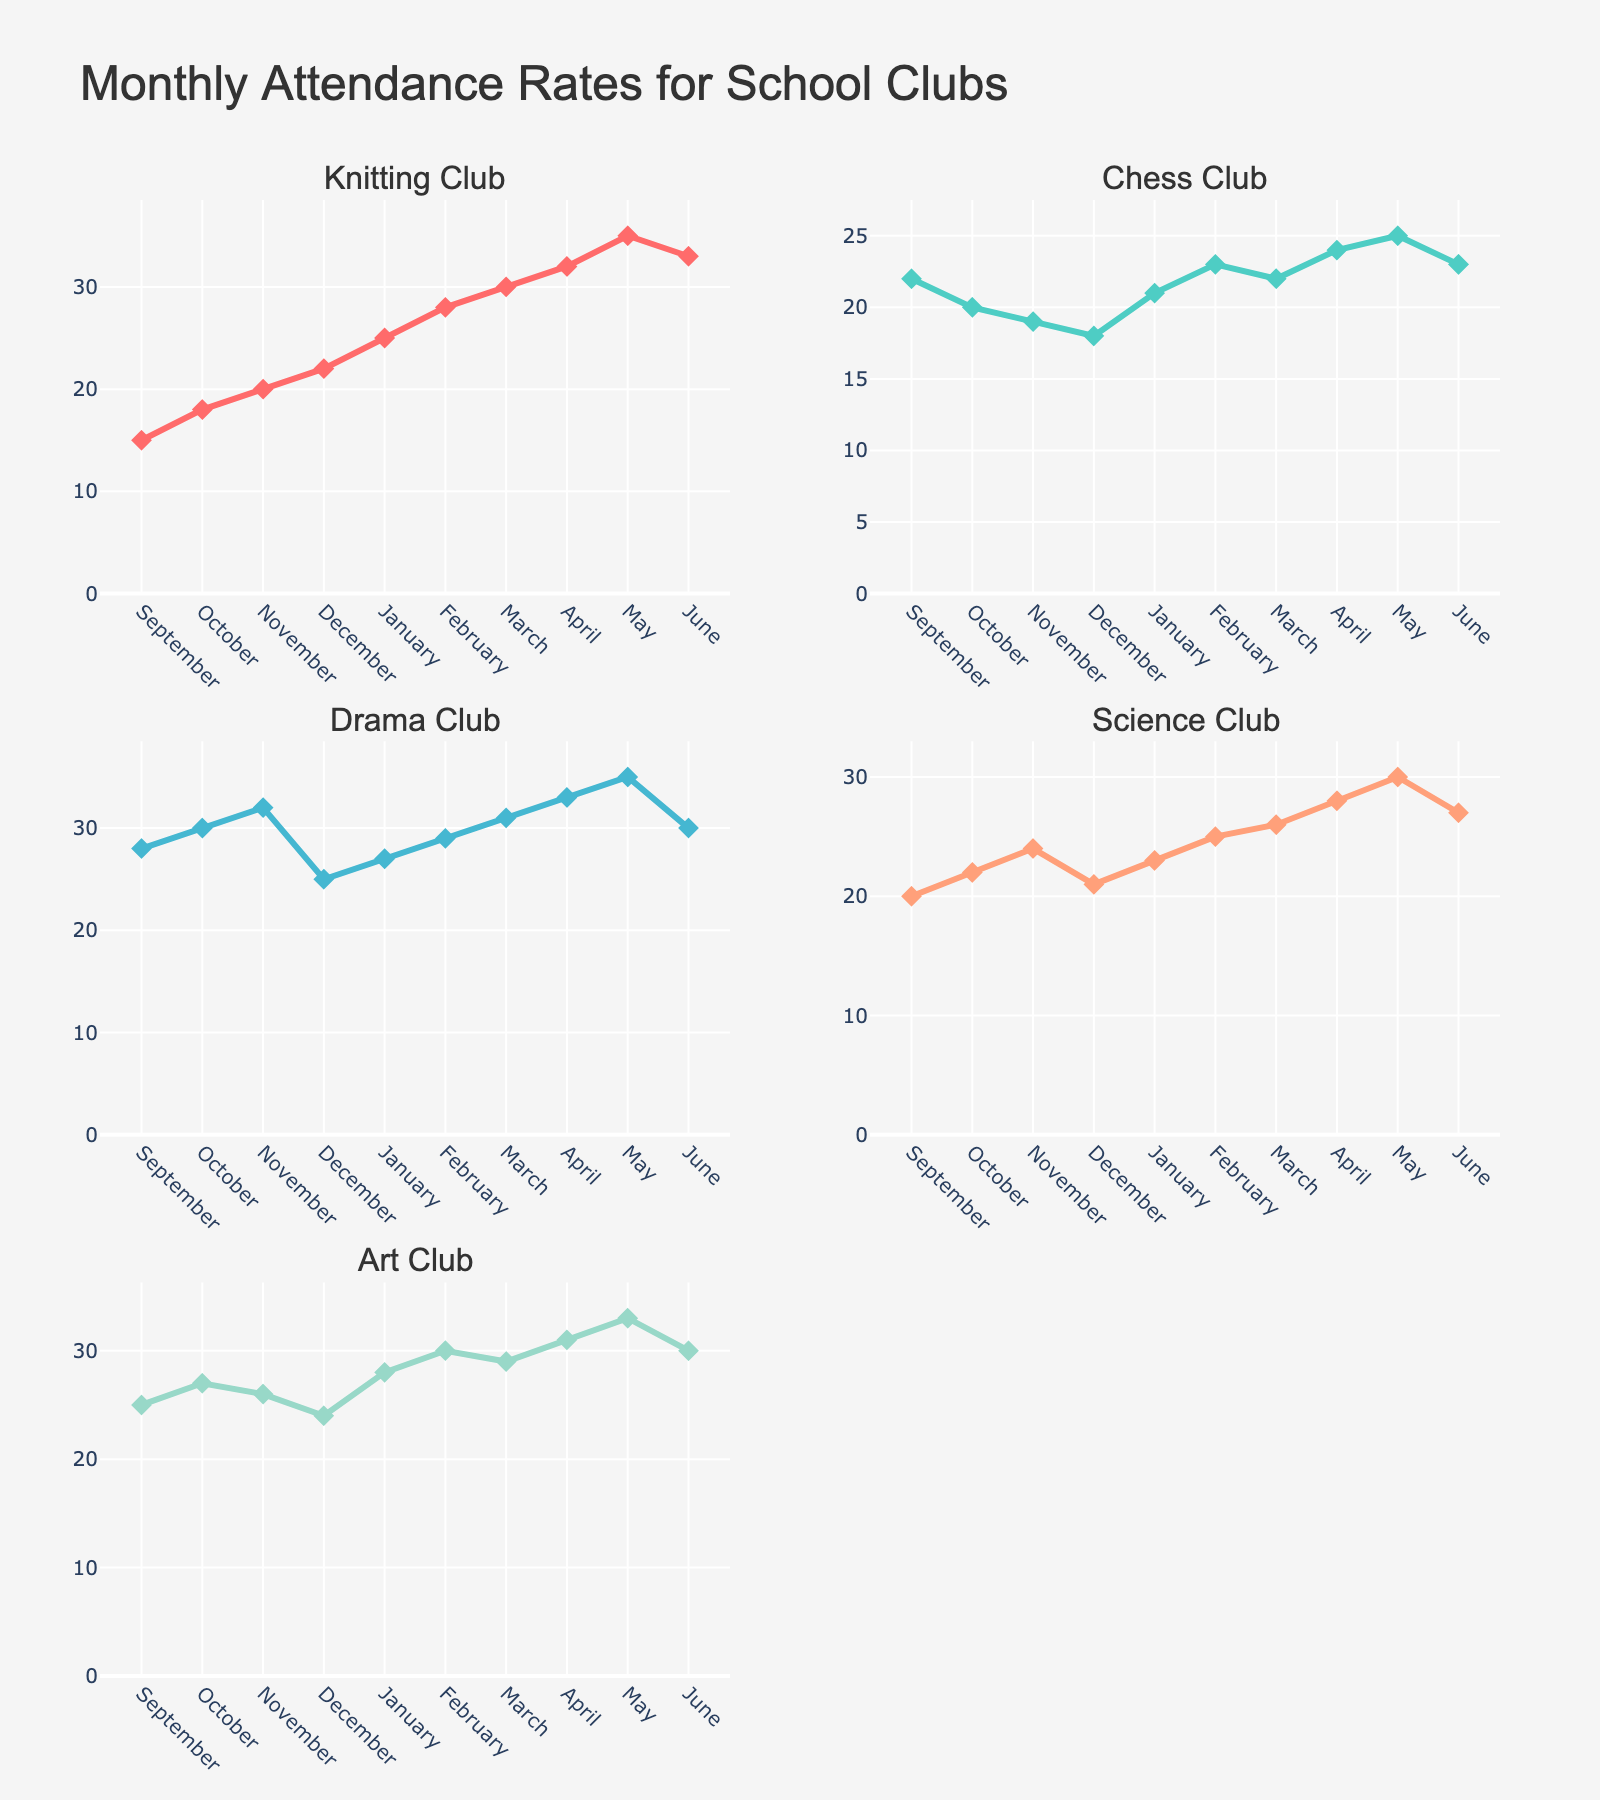What is the title of the plot? The title is usually displayed at the top of the figure. In this case, it reads "Monthly Attendance Rates for School Clubs".
Answer: Monthly Attendance Rates for School Clubs How many subplots are in the figure? The figure has two columns and three rows of subplots, which makes a total of 6 subplots.
Answer: 6 In which month did the Knitting Club have the highest attendance? The Knitting Club plot shows the highest value in May, reaching 35.
Answer: May Which club had the lowest attendance rate in December? By observing the December data points across all subplots, the Drama Club has the lowest attendance rate in December, which is 18.
Answer: Drama Club What is the average attendance of the Science Club for the academic year? Sum the attendance values for the Science Club: 20 + 22 + 24 + 21 + 23 + 25 + 26 + 28 + 30 + 27 = 246. Divide by the number of months: 246 / 10 = 24.6.
Answer: 24.6 Which two clubs have attendance patterns that are most closely aligned? By comparing the line patterns, the attendance curves of the Science Club and Chess Club appear to fluctuate similarly, particularly in the middle months.
Answer: Science Club and Chess Club How does the trend of the Art Club's attendance change from January to June? From January to June, the Art Club's attendance starts at 28, increases to 30 in February, drops to 29 in March, rises to 31 in April, peaks at 33 in May, and decreases again to 30 in June. This shows an overall increasing trend with slight fluctuations.
Answer: Overall increasing with fluctuations Which club showed a consistent increase in attendance over the academic year? The Knitting Club's attendance values start at 15 in September and generally increase month-over-month, reaching a peak of 35 in May before slightly dropping in June.
Answer: Knitting Club In November, how much higher was the Drama Club attendance compared to the Art Club? The Drama Club had an attendance of 32 in November, while the Art Club had 26. The difference is 32 - 26 = 6.
Answer: 6 In which month did the Chess Club have its second highest attendance? Observing the Chess Club plot, the highest attendance is in May (25), and the second highest is seen in February (23).
Answer: February 